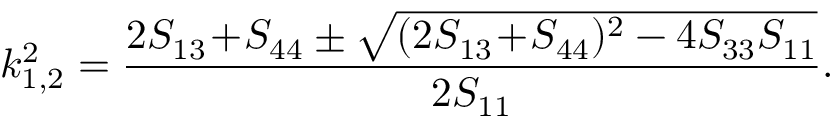<formula> <loc_0><loc_0><loc_500><loc_500>k _ { 1 , 2 } ^ { 2 } = \frac { 2 S _ { 1 3 } \, + \, S _ { 4 4 } \pm \sqrt { ( 2 S _ { 1 3 } \, + \, S _ { 4 4 } ) ^ { 2 } - 4 S _ { 3 3 } S _ { 1 1 } } } { 2 S _ { 1 1 } } .</formula> 